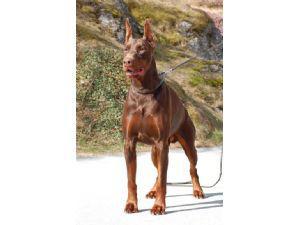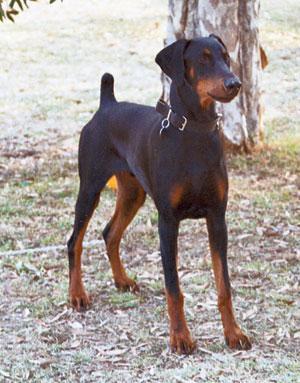The first image is the image on the left, the second image is the image on the right. Analyze the images presented: Is the assertion "The left image contains two dogs." valid? Answer yes or no. No. The first image is the image on the left, the second image is the image on the right. Evaluate the accuracy of this statement regarding the images: "Each image contains multiple dobermans, at least one image shows dobermans in front of water, and one image shows exactly two pointy-eared dobermans side-by-side.". Is it true? Answer yes or no. No. 